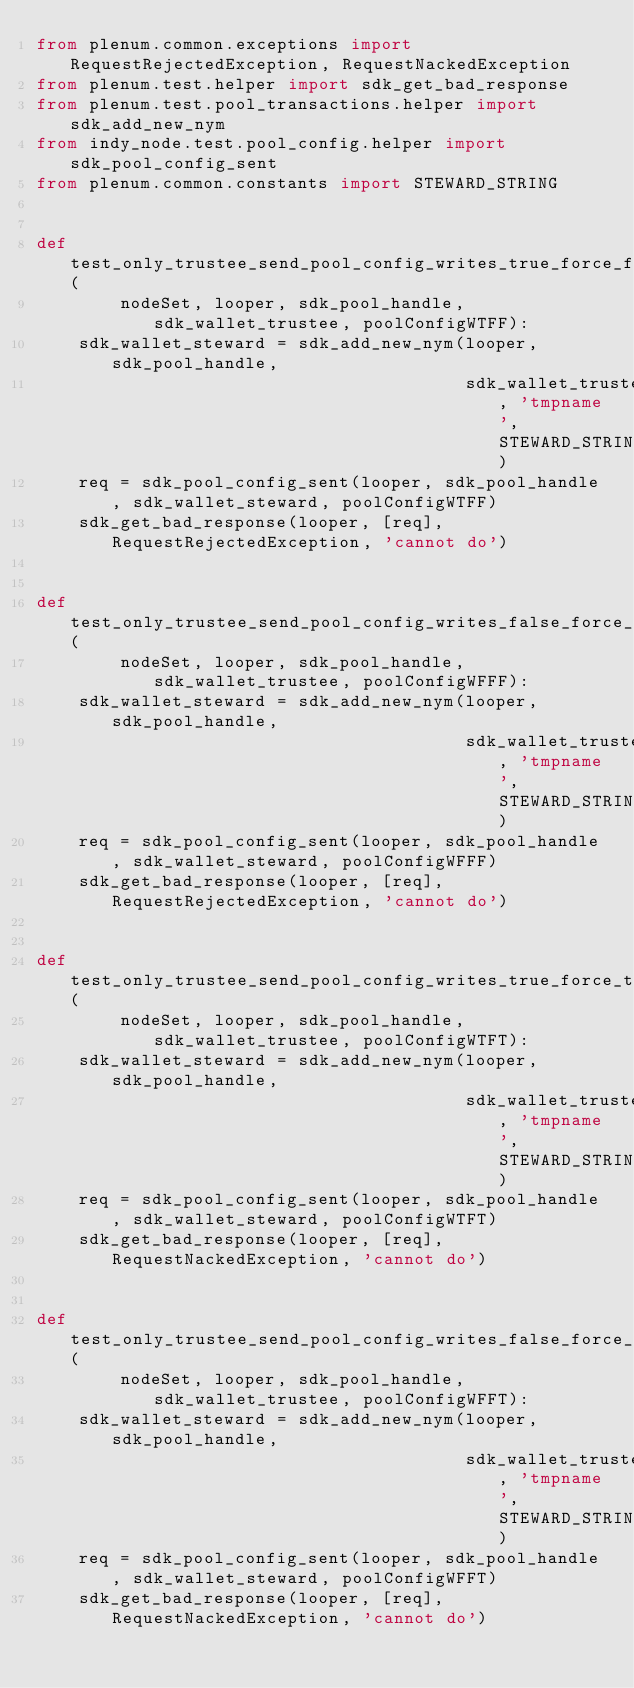Convert code to text. <code><loc_0><loc_0><loc_500><loc_500><_Python_>from plenum.common.exceptions import RequestRejectedException, RequestNackedException
from plenum.test.helper import sdk_get_bad_response
from plenum.test.pool_transactions.helper import sdk_add_new_nym
from indy_node.test.pool_config.helper import sdk_pool_config_sent
from plenum.common.constants import STEWARD_STRING


def test_only_trustee_send_pool_config_writes_true_force_false(
        nodeSet, looper, sdk_pool_handle, sdk_wallet_trustee, poolConfigWTFF):
    sdk_wallet_steward = sdk_add_new_nym(looper, sdk_pool_handle,
                                         sdk_wallet_trustee, 'tmpname', STEWARD_STRING)
    req = sdk_pool_config_sent(looper, sdk_pool_handle, sdk_wallet_steward, poolConfigWTFF)
    sdk_get_bad_response(looper, [req], RequestRejectedException, 'cannot do')


def test_only_trustee_send_pool_config_writes_false_force_false(
        nodeSet, looper, sdk_pool_handle, sdk_wallet_trustee, poolConfigWFFF):
    sdk_wallet_steward = sdk_add_new_nym(looper, sdk_pool_handle,
                                         sdk_wallet_trustee, 'tmpname', STEWARD_STRING)
    req = sdk_pool_config_sent(looper, sdk_pool_handle, sdk_wallet_steward, poolConfigWFFF)
    sdk_get_bad_response(looper, [req], RequestRejectedException, 'cannot do')


def test_only_trustee_send_pool_config_writes_true_force_true(
        nodeSet, looper, sdk_pool_handle, sdk_wallet_trustee, poolConfigWTFT):
    sdk_wallet_steward = sdk_add_new_nym(looper, sdk_pool_handle,
                                         sdk_wallet_trustee, 'tmpname', STEWARD_STRING)
    req = sdk_pool_config_sent(looper, sdk_pool_handle, sdk_wallet_steward, poolConfigWTFT)
    sdk_get_bad_response(looper, [req], RequestNackedException, 'cannot do')


def test_only_trustee_send_pool_config_writes_false_force_true(
        nodeSet, looper, sdk_pool_handle, sdk_wallet_trustee, poolConfigWFFT):
    sdk_wallet_steward = sdk_add_new_nym(looper, sdk_pool_handle,
                                         sdk_wallet_trustee, 'tmpname', STEWARD_STRING)
    req = sdk_pool_config_sent(looper, sdk_pool_handle, sdk_wallet_steward, poolConfigWFFT)
    sdk_get_bad_response(looper, [req], RequestNackedException, 'cannot do')
</code> 